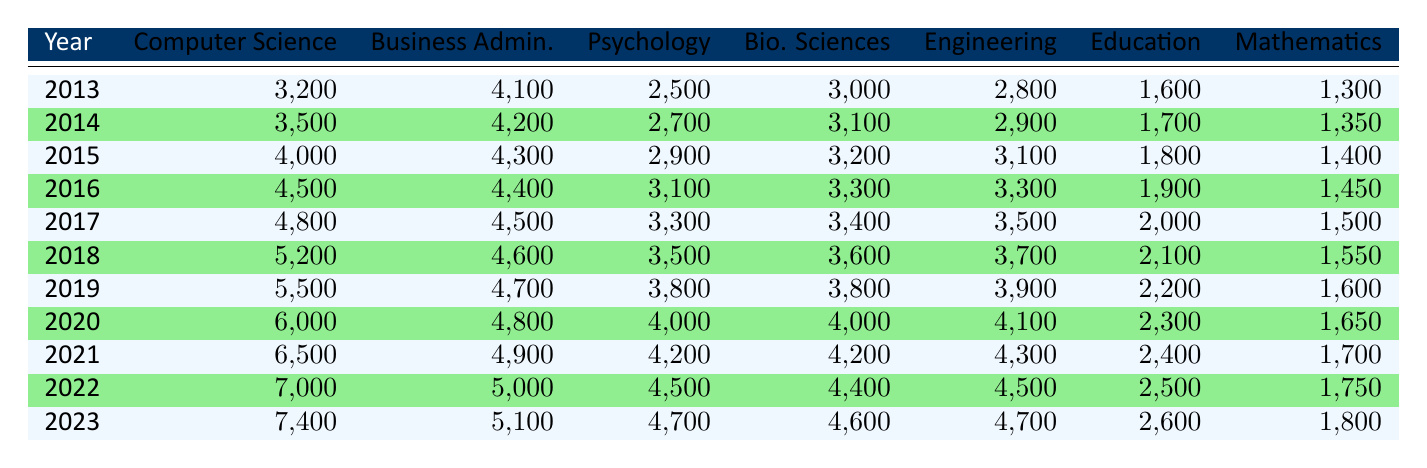What was the enrollment for Computer Science in 2016? In 2016, the table indicates the enrollment number for Computer Science is listed under that major in the table for the year 2016. The corresponding value is 4500.
Answer: 4500 What was the total enrollment for all majors in 2020? To find the total enrollment in 2020, I will sum the enrollment numbers for all majors listed in that year: 6000 (CS) + 4800 (BA) + 4000 (Psych) + 4000 (Bio. Sci) + 4100 (Eng) + 2300 (Edu) + 1650 (Math) = 22600.
Answer: 22600 Did the enrollment for Education increase from 2013 to 2023? By comparing the enrollment figures for Education in 2013 (1600) and 2023 (2600), I can see that the number has increased over the decade.
Answer: Yes What is the average enrollment for Business Administration from 2013 to 2023? I will sum the enrollment numbers for Business Administration from each year (4100, 4200, 4300, 4400, 4500, 4600, 4700, 4800, 4900, 5000, 5100) and then divide by the total number of years (11): (4100 + 4200 + 4300 + 4400 + 4500 + 4600 + 4700 + 4800 + 4900 + 5000 + 5100) = 48900, then 48900 / 11 = 4445.45, rounded to 4445 when taking whole students.
Answer: 4445 Which major had the highest enrollment in 2022? Reviewing the enrollment numbers in the year 2022, the major with the highest enrollment is Computer Science at 7000.
Answer: Computer Science What was the percentage increase in enrollment for Psychology from 2013 to 2023? To find the percentage increase, I can calculate the difference in enrollment for Psychology between these years: 2023 (4700) - 2013 (2500) = 2200. Then, I divide by the original enrollment number in 2013 and multiply by 100: (2200 / 2500) * 100 = 88%.
Answer: 88% Is it true that Engineering had the same enrollment number in 2017 and 2018? I will check the numbers for Engineering in both years: 2017 (3500) and 2018 (3700) indicate they are different. 3500 does not equal 3700.
Answer: No What is the enrollment trend for Mathematics from 2013 to 2023? To analyze the trend, I can compare the enrollment numbers for Mathematics over the years: 1300 (2013), 1350 (2014), 1400 (2015), 1450 (2016), 1500 (2017), 1550 (2018), 1600 (2019), 1650 (2020), 1700 (2021), 1750 (2022), 1800 (2023). The enrollment has consistently increased each year.
Answer: Consistent increase 